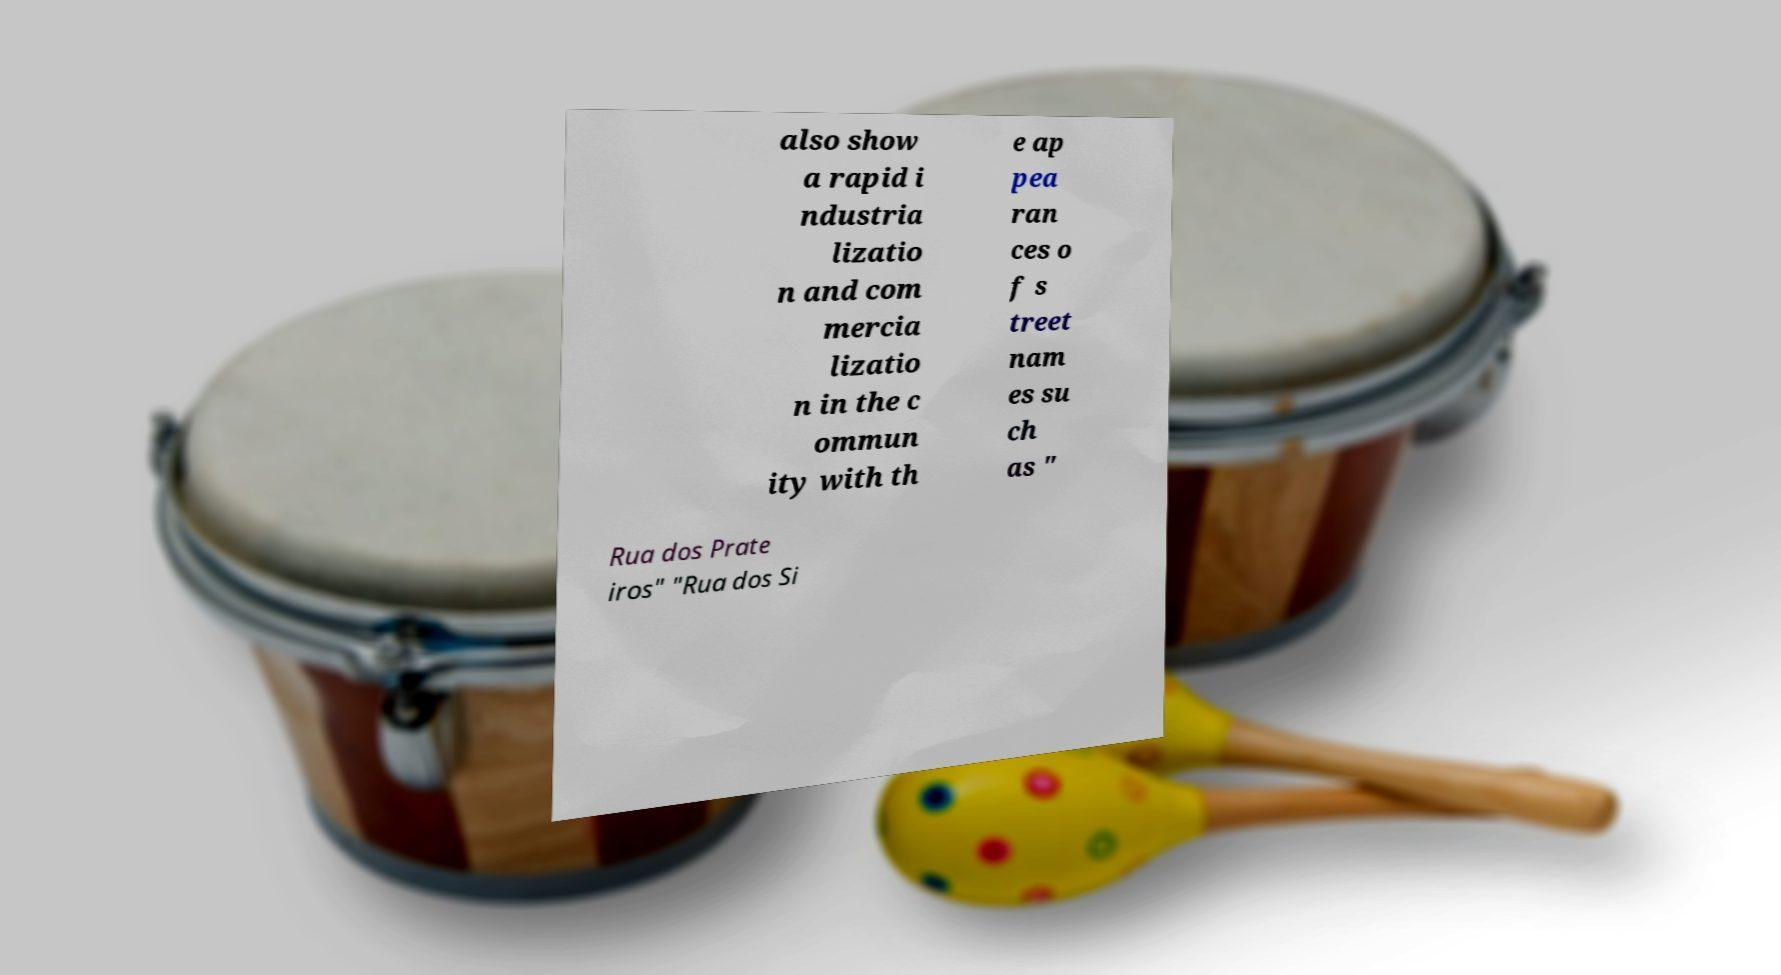Can you read and provide the text displayed in the image?This photo seems to have some interesting text. Can you extract and type it out for me? also show a rapid i ndustria lizatio n and com mercia lizatio n in the c ommun ity with th e ap pea ran ces o f s treet nam es su ch as " Rua dos Prate iros" "Rua dos Si 